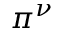Convert formula to latex. <formula><loc_0><loc_0><loc_500><loc_500>\pi ^ { \nu }</formula> 